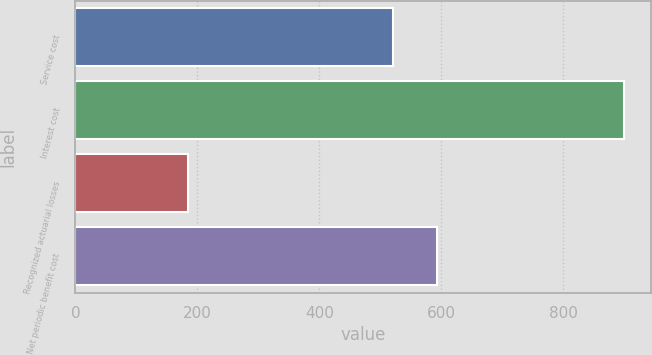Convert chart to OTSL. <chart><loc_0><loc_0><loc_500><loc_500><bar_chart><fcel>Service cost<fcel>Interest cost<fcel>Recognized actuarial losses<fcel>Net periodic benefit cost<nl><fcel>521<fcel>900<fcel>184<fcel>592.6<nl></chart> 